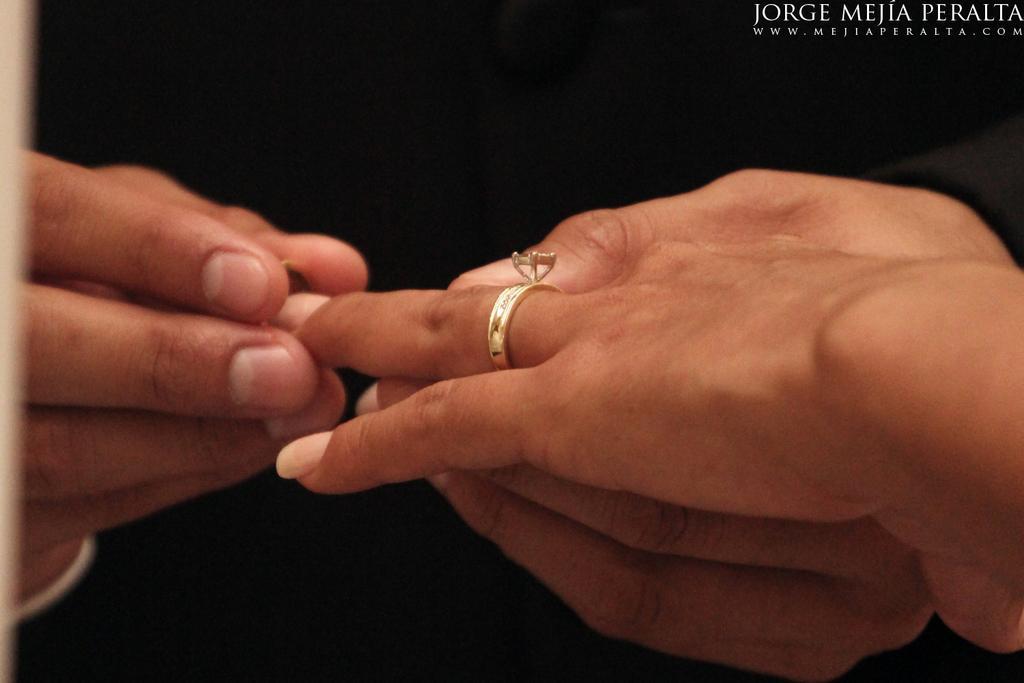In one or two sentences, can you explain what this image depicts? In the image in the center we can see human hands and two rings. On the top right of the image,there is a watermark. 